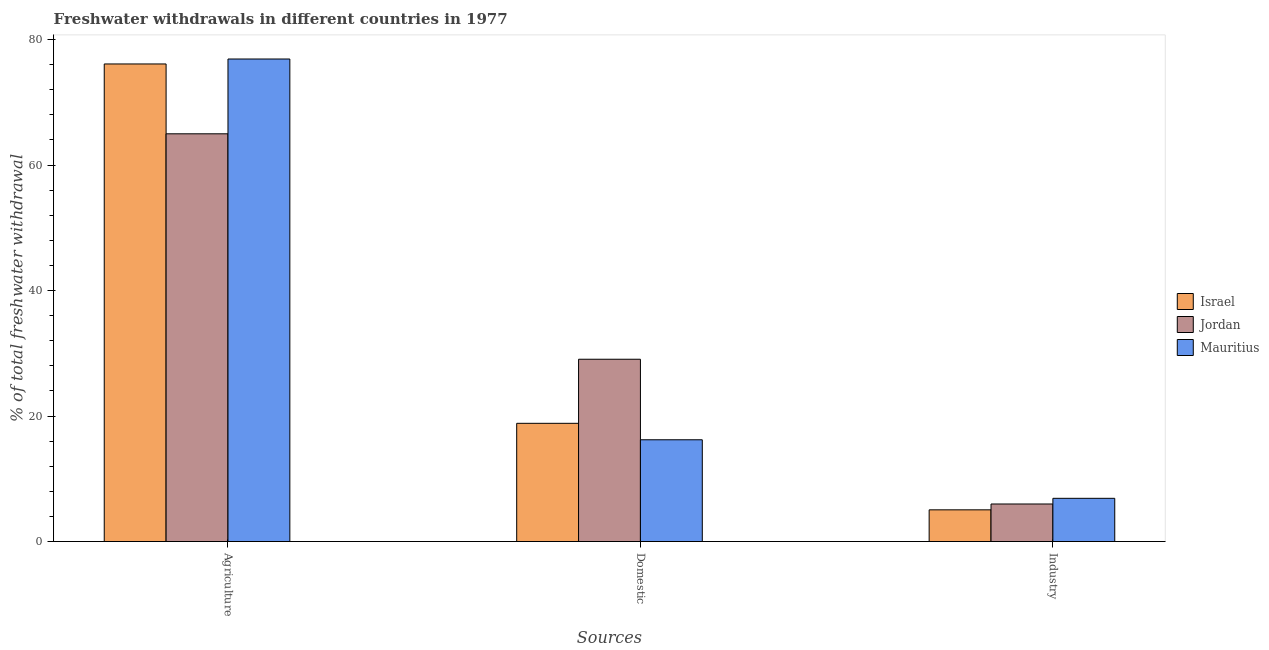How many different coloured bars are there?
Your answer should be very brief. 3. How many groups of bars are there?
Your answer should be compact. 3. Are the number of bars per tick equal to the number of legend labels?
Provide a succinct answer. Yes. Are the number of bars on each tick of the X-axis equal?
Your answer should be very brief. Yes. What is the label of the 2nd group of bars from the left?
Make the answer very short. Domestic. What is the percentage of freshwater withdrawal for agriculture in Mauritius?
Keep it short and to the point. 76.89. Across all countries, what is the maximum percentage of freshwater withdrawal for industry?
Your answer should be very brief. 6.89. Across all countries, what is the minimum percentage of freshwater withdrawal for agriculture?
Offer a terse response. 64.97. In which country was the percentage of freshwater withdrawal for agriculture maximum?
Provide a short and direct response. Mauritius. In which country was the percentage of freshwater withdrawal for agriculture minimum?
Make the answer very short. Jordan. What is the total percentage of freshwater withdrawal for agriculture in the graph?
Give a very brief answer. 217.96. What is the difference between the percentage of freshwater withdrawal for agriculture in Jordan and that in Mauritius?
Provide a short and direct response. -11.92. What is the difference between the percentage of freshwater withdrawal for industry in Mauritius and the percentage of freshwater withdrawal for agriculture in Israel?
Provide a short and direct response. -69.21. What is the average percentage of freshwater withdrawal for agriculture per country?
Your response must be concise. 72.65. What is the difference between the percentage of freshwater withdrawal for industry and percentage of freshwater withdrawal for agriculture in Jordan?
Provide a succinct answer. -58.98. What is the ratio of the percentage of freshwater withdrawal for industry in Jordan to that in Israel?
Provide a succinct answer. 1.18. Is the percentage of freshwater withdrawal for domestic purposes in Mauritius less than that in Jordan?
Provide a succinct answer. Yes. What is the difference between the highest and the second highest percentage of freshwater withdrawal for agriculture?
Your answer should be very brief. 0.79. What is the difference between the highest and the lowest percentage of freshwater withdrawal for industry?
Make the answer very short. 1.83. What does the 2nd bar from the left in Domestic represents?
Your response must be concise. Jordan. What does the 2nd bar from the right in Domestic represents?
Give a very brief answer. Jordan. How many bars are there?
Make the answer very short. 9. Are all the bars in the graph horizontal?
Provide a short and direct response. No. Are the values on the major ticks of Y-axis written in scientific E-notation?
Provide a short and direct response. No. Does the graph contain any zero values?
Ensure brevity in your answer.  No. What is the title of the graph?
Keep it short and to the point. Freshwater withdrawals in different countries in 1977. Does "Senegal" appear as one of the legend labels in the graph?
Make the answer very short. No. What is the label or title of the X-axis?
Provide a succinct answer. Sources. What is the label or title of the Y-axis?
Offer a terse response. % of total freshwater withdrawal. What is the % of total freshwater withdrawal of Israel in Agriculture?
Offer a very short reply. 76.1. What is the % of total freshwater withdrawal in Jordan in Agriculture?
Offer a terse response. 64.97. What is the % of total freshwater withdrawal of Mauritius in Agriculture?
Your answer should be very brief. 76.89. What is the % of total freshwater withdrawal in Israel in Domestic?
Your response must be concise. 18.84. What is the % of total freshwater withdrawal of Jordan in Domestic?
Ensure brevity in your answer.  29.05. What is the % of total freshwater withdrawal in Mauritius in Domestic?
Make the answer very short. 16.22. What is the % of total freshwater withdrawal of Israel in Industry?
Make the answer very short. 5.05. What is the % of total freshwater withdrawal of Jordan in Industry?
Offer a very short reply. 5.99. What is the % of total freshwater withdrawal in Mauritius in Industry?
Your answer should be very brief. 6.89. Across all Sources, what is the maximum % of total freshwater withdrawal in Israel?
Provide a succinct answer. 76.1. Across all Sources, what is the maximum % of total freshwater withdrawal of Jordan?
Ensure brevity in your answer.  64.97. Across all Sources, what is the maximum % of total freshwater withdrawal of Mauritius?
Provide a succinct answer. 76.89. Across all Sources, what is the minimum % of total freshwater withdrawal of Israel?
Give a very brief answer. 5.05. Across all Sources, what is the minimum % of total freshwater withdrawal in Jordan?
Keep it short and to the point. 5.99. Across all Sources, what is the minimum % of total freshwater withdrawal in Mauritius?
Provide a succinct answer. 6.89. What is the total % of total freshwater withdrawal in Israel in the graph?
Your answer should be compact. 100. What is the total % of total freshwater withdrawal in Jordan in the graph?
Make the answer very short. 100.01. What is the total % of total freshwater withdrawal of Mauritius in the graph?
Keep it short and to the point. 100. What is the difference between the % of total freshwater withdrawal of Israel in Agriculture and that in Domestic?
Your response must be concise. 57.26. What is the difference between the % of total freshwater withdrawal of Jordan in Agriculture and that in Domestic?
Give a very brief answer. 35.92. What is the difference between the % of total freshwater withdrawal of Mauritius in Agriculture and that in Domestic?
Give a very brief answer. 60.67. What is the difference between the % of total freshwater withdrawal of Israel in Agriculture and that in Industry?
Provide a short and direct response. 71.05. What is the difference between the % of total freshwater withdrawal of Jordan in Agriculture and that in Industry?
Ensure brevity in your answer.  58.98. What is the difference between the % of total freshwater withdrawal in Mauritius in Agriculture and that in Industry?
Ensure brevity in your answer.  70. What is the difference between the % of total freshwater withdrawal of Israel in Domestic and that in Industry?
Make the answer very short. 13.79. What is the difference between the % of total freshwater withdrawal in Jordan in Domestic and that in Industry?
Ensure brevity in your answer.  23.06. What is the difference between the % of total freshwater withdrawal of Mauritius in Domestic and that in Industry?
Ensure brevity in your answer.  9.33. What is the difference between the % of total freshwater withdrawal in Israel in Agriculture and the % of total freshwater withdrawal in Jordan in Domestic?
Make the answer very short. 47.05. What is the difference between the % of total freshwater withdrawal in Israel in Agriculture and the % of total freshwater withdrawal in Mauritius in Domestic?
Offer a terse response. 59.88. What is the difference between the % of total freshwater withdrawal in Jordan in Agriculture and the % of total freshwater withdrawal in Mauritius in Domestic?
Make the answer very short. 48.75. What is the difference between the % of total freshwater withdrawal of Israel in Agriculture and the % of total freshwater withdrawal of Jordan in Industry?
Provide a short and direct response. 70.11. What is the difference between the % of total freshwater withdrawal in Israel in Agriculture and the % of total freshwater withdrawal in Mauritius in Industry?
Offer a very short reply. 69.21. What is the difference between the % of total freshwater withdrawal of Jordan in Agriculture and the % of total freshwater withdrawal of Mauritius in Industry?
Provide a succinct answer. 58.08. What is the difference between the % of total freshwater withdrawal in Israel in Domestic and the % of total freshwater withdrawal in Jordan in Industry?
Keep it short and to the point. 12.85. What is the difference between the % of total freshwater withdrawal of Israel in Domestic and the % of total freshwater withdrawal of Mauritius in Industry?
Ensure brevity in your answer.  11.95. What is the difference between the % of total freshwater withdrawal in Jordan in Domestic and the % of total freshwater withdrawal in Mauritius in Industry?
Ensure brevity in your answer.  22.16. What is the average % of total freshwater withdrawal in Israel per Sources?
Your answer should be very brief. 33.33. What is the average % of total freshwater withdrawal in Jordan per Sources?
Your response must be concise. 33.34. What is the average % of total freshwater withdrawal in Mauritius per Sources?
Your response must be concise. 33.33. What is the difference between the % of total freshwater withdrawal of Israel and % of total freshwater withdrawal of Jordan in Agriculture?
Provide a short and direct response. 11.13. What is the difference between the % of total freshwater withdrawal of Israel and % of total freshwater withdrawal of Mauritius in Agriculture?
Keep it short and to the point. -0.79. What is the difference between the % of total freshwater withdrawal of Jordan and % of total freshwater withdrawal of Mauritius in Agriculture?
Your answer should be compact. -11.92. What is the difference between the % of total freshwater withdrawal in Israel and % of total freshwater withdrawal in Jordan in Domestic?
Keep it short and to the point. -10.21. What is the difference between the % of total freshwater withdrawal of Israel and % of total freshwater withdrawal of Mauritius in Domestic?
Keep it short and to the point. 2.62. What is the difference between the % of total freshwater withdrawal of Jordan and % of total freshwater withdrawal of Mauritius in Domestic?
Ensure brevity in your answer.  12.83. What is the difference between the % of total freshwater withdrawal in Israel and % of total freshwater withdrawal in Jordan in Industry?
Offer a terse response. -0.93. What is the difference between the % of total freshwater withdrawal of Israel and % of total freshwater withdrawal of Mauritius in Industry?
Provide a short and direct response. -1.83. What is the difference between the % of total freshwater withdrawal in Jordan and % of total freshwater withdrawal in Mauritius in Industry?
Offer a very short reply. -0.9. What is the ratio of the % of total freshwater withdrawal in Israel in Agriculture to that in Domestic?
Ensure brevity in your answer.  4.04. What is the ratio of the % of total freshwater withdrawal of Jordan in Agriculture to that in Domestic?
Your answer should be compact. 2.24. What is the ratio of the % of total freshwater withdrawal in Mauritius in Agriculture to that in Domestic?
Provide a short and direct response. 4.74. What is the ratio of the % of total freshwater withdrawal in Israel in Agriculture to that in Industry?
Provide a short and direct response. 15.05. What is the ratio of the % of total freshwater withdrawal in Jordan in Agriculture to that in Industry?
Provide a short and direct response. 10.85. What is the ratio of the % of total freshwater withdrawal of Mauritius in Agriculture to that in Industry?
Ensure brevity in your answer.  11.16. What is the ratio of the % of total freshwater withdrawal in Israel in Domestic to that in Industry?
Offer a very short reply. 3.73. What is the ratio of the % of total freshwater withdrawal in Jordan in Domestic to that in Industry?
Provide a succinct answer. 4.85. What is the ratio of the % of total freshwater withdrawal in Mauritius in Domestic to that in Industry?
Offer a terse response. 2.35. What is the difference between the highest and the second highest % of total freshwater withdrawal of Israel?
Give a very brief answer. 57.26. What is the difference between the highest and the second highest % of total freshwater withdrawal in Jordan?
Make the answer very short. 35.92. What is the difference between the highest and the second highest % of total freshwater withdrawal of Mauritius?
Your answer should be very brief. 60.67. What is the difference between the highest and the lowest % of total freshwater withdrawal of Israel?
Offer a very short reply. 71.05. What is the difference between the highest and the lowest % of total freshwater withdrawal of Jordan?
Provide a succinct answer. 58.98. What is the difference between the highest and the lowest % of total freshwater withdrawal of Mauritius?
Make the answer very short. 70. 